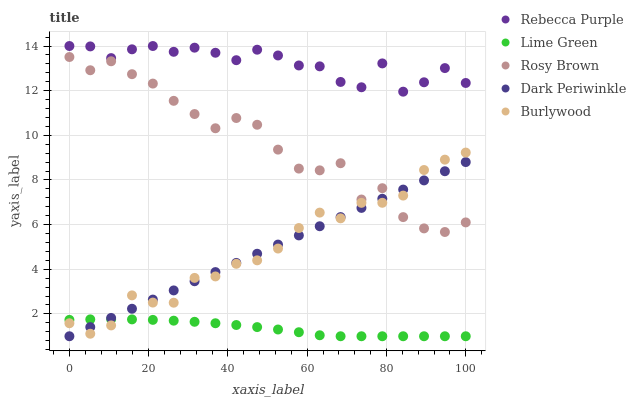Does Lime Green have the minimum area under the curve?
Answer yes or no. Yes. Does Rebecca Purple have the maximum area under the curve?
Answer yes or no. Yes. Does Rosy Brown have the minimum area under the curve?
Answer yes or no. No. Does Rosy Brown have the maximum area under the curve?
Answer yes or no. No. Is Dark Periwinkle the smoothest?
Answer yes or no. Yes. Is Rosy Brown the roughest?
Answer yes or no. Yes. Is Lime Green the smoothest?
Answer yes or no. No. Is Lime Green the roughest?
Answer yes or no. No. Does Lime Green have the lowest value?
Answer yes or no. Yes. Does Rosy Brown have the lowest value?
Answer yes or no. No. Does Rebecca Purple have the highest value?
Answer yes or no. Yes. Does Rosy Brown have the highest value?
Answer yes or no. No. Is Dark Periwinkle less than Rebecca Purple?
Answer yes or no. Yes. Is Rebecca Purple greater than Dark Periwinkle?
Answer yes or no. Yes. Does Dark Periwinkle intersect Rosy Brown?
Answer yes or no. Yes. Is Dark Periwinkle less than Rosy Brown?
Answer yes or no. No. Is Dark Periwinkle greater than Rosy Brown?
Answer yes or no. No. Does Dark Periwinkle intersect Rebecca Purple?
Answer yes or no. No. 